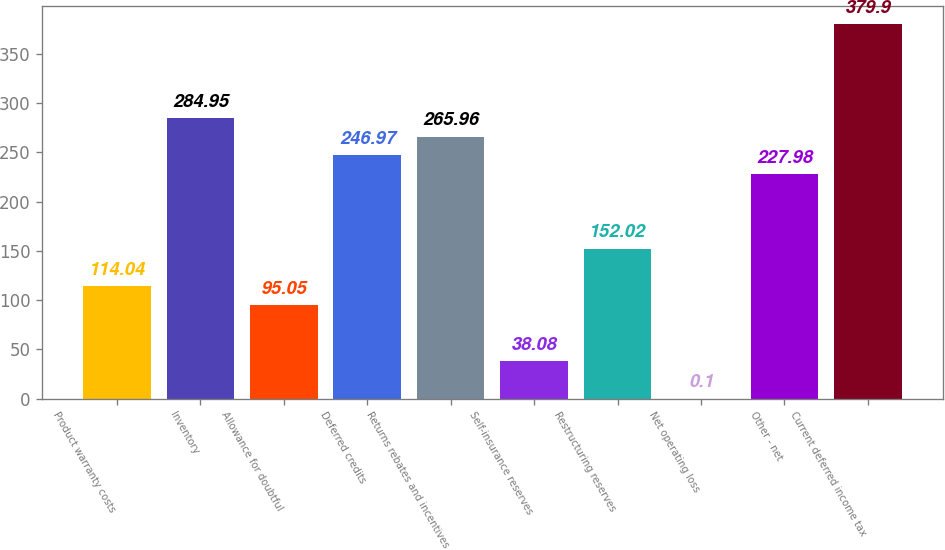<chart> <loc_0><loc_0><loc_500><loc_500><bar_chart><fcel>Product warranty costs<fcel>Inventory<fcel>Allowance for doubtful<fcel>Deferred credits<fcel>Returns rebates and incentives<fcel>Self-insurance reserves<fcel>Restructuring reserves<fcel>Net operating loss<fcel>Other - net<fcel>Current deferred income tax<nl><fcel>114.04<fcel>284.95<fcel>95.05<fcel>246.97<fcel>265.96<fcel>38.08<fcel>152.02<fcel>0.1<fcel>227.98<fcel>379.9<nl></chart> 